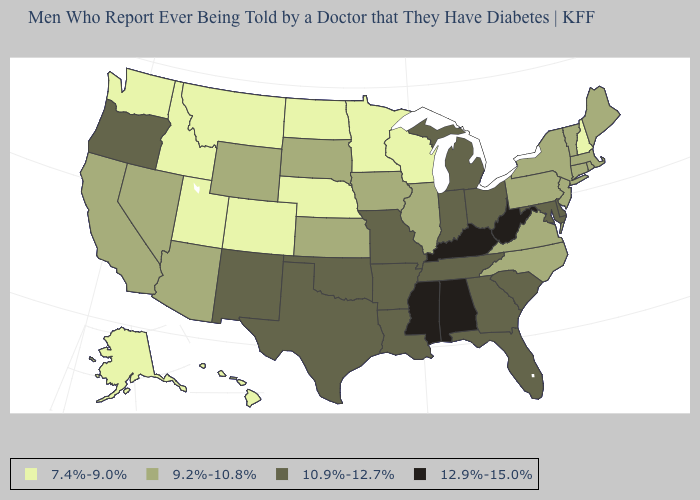Does New Hampshire have the lowest value in the USA?
Concise answer only. Yes. What is the value of West Virginia?
Give a very brief answer. 12.9%-15.0%. How many symbols are there in the legend?
Answer briefly. 4. Name the states that have a value in the range 10.9%-12.7%?
Quick response, please. Arkansas, Delaware, Florida, Georgia, Indiana, Louisiana, Maryland, Michigan, Missouri, New Mexico, Ohio, Oklahoma, Oregon, South Carolina, Tennessee, Texas. What is the value of Michigan?
Quick response, please. 10.9%-12.7%. Does New Hampshire have the lowest value in the USA?
Concise answer only. Yes. Name the states that have a value in the range 7.4%-9.0%?
Short answer required. Alaska, Colorado, Hawaii, Idaho, Minnesota, Montana, Nebraska, New Hampshire, North Dakota, Utah, Washington, Wisconsin. Does Colorado have the lowest value in the USA?
Short answer required. Yes. What is the highest value in the West ?
Give a very brief answer. 10.9%-12.7%. What is the value of Washington?
Write a very short answer. 7.4%-9.0%. What is the lowest value in states that border Montana?
Write a very short answer. 7.4%-9.0%. Name the states that have a value in the range 7.4%-9.0%?
Give a very brief answer. Alaska, Colorado, Hawaii, Idaho, Minnesota, Montana, Nebraska, New Hampshire, North Dakota, Utah, Washington, Wisconsin. Name the states that have a value in the range 9.2%-10.8%?
Write a very short answer. Arizona, California, Connecticut, Illinois, Iowa, Kansas, Maine, Massachusetts, Nevada, New Jersey, New York, North Carolina, Pennsylvania, Rhode Island, South Dakota, Vermont, Virginia, Wyoming. What is the value of Florida?
Give a very brief answer. 10.9%-12.7%. What is the value of Iowa?
Answer briefly. 9.2%-10.8%. 